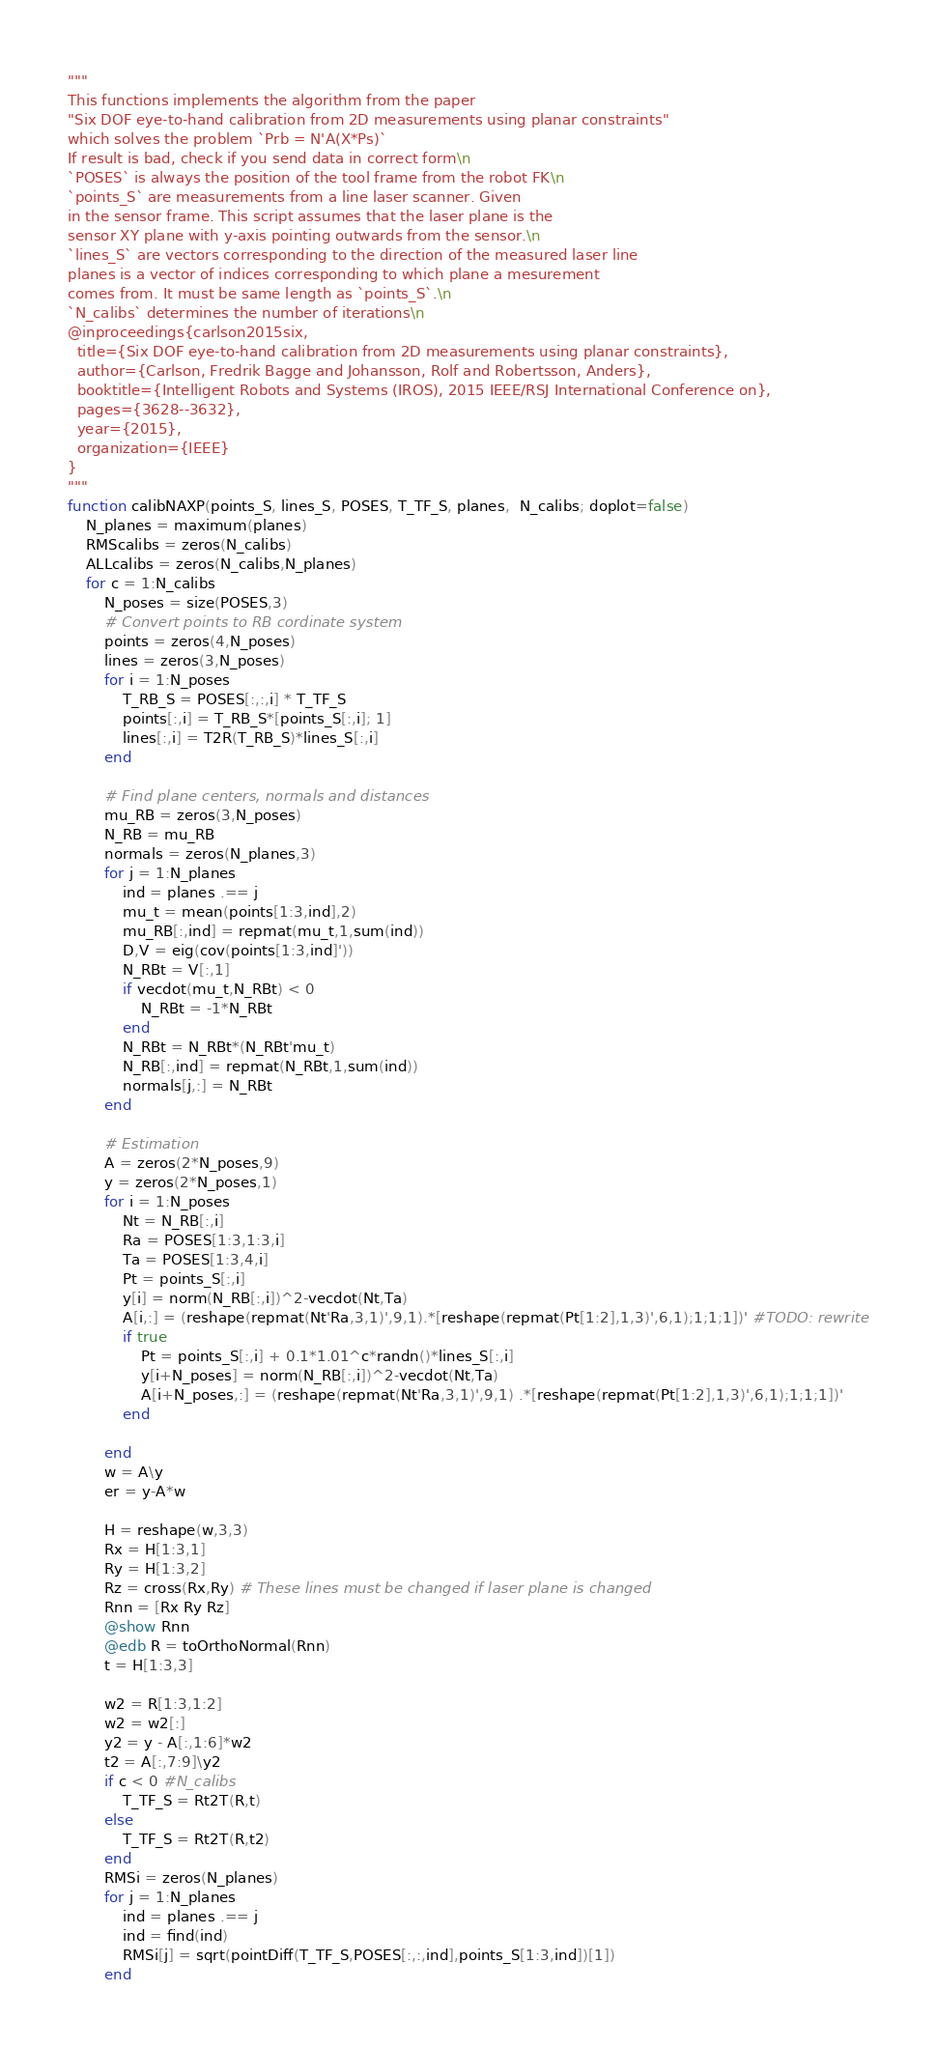Convert code to text. <code><loc_0><loc_0><loc_500><loc_500><_Julia_>"""
This functions implements the algorithm from the paper
"Six DOF eye-to-hand calibration from 2D measurements using planar constraints"
which solves the problem `Prb = N'A(X*Ps)`
If result is bad, check if you send data in correct form\n
`POSES` is always the position of the tool frame from the robot FK\n
`points_S` are measurements from a line laser scanner. Given
in the sensor frame. This script assumes that the laser plane is the
sensor XY plane with y-axis pointing outwards from the sensor.\n
`lines_S` are vectors corresponding to the direction of the measured laser line
planes is a vector of indices corresponding to which plane a mesurement
comes from. It must be same length as `points_S`.\n
`N_calibs` determines the number of iterations\n
@inproceedings{carlson2015six,
  title={Six DOF eye-to-hand calibration from 2D measurements using planar constraints},
  author={Carlson, Fredrik Bagge and Johansson, Rolf and Robertsson, Anders},
  booktitle={Intelligent Robots and Systems (IROS), 2015 IEEE/RSJ International Conference on},
  pages={3628--3632},
  year={2015},
  organization={IEEE}
}
"""
function calibNAXP(points_S, lines_S, POSES, T_TF_S, planes,  N_calibs; doplot=false)
    N_planes = maximum(planes)
    RMScalibs = zeros(N_calibs)
    ALLcalibs = zeros(N_calibs,N_planes)
    for c = 1:N_calibs
        N_poses = size(POSES,3)
        # Convert points to RB cordinate system
        points = zeros(4,N_poses)
        lines = zeros(3,N_poses)
        for i = 1:N_poses
            T_RB_S = POSES[:,:,i] * T_TF_S
            points[:,i] = T_RB_S*[points_S[:,i]; 1]
            lines[:,i] = T2R(T_RB_S)*lines_S[:,i]
        end

        # Find plane centers, normals and distances
        mu_RB = zeros(3,N_poses)
        N_RB = mu_RB
        normals = zeros(N_planes,3)
        for j = 1:N_planes
            ind = planes .== j
            mu_t = mean(points[1:3,ind],2)
            mu_RB[:,ind] = repmat(mu_t,1,sum(ind))
            D,V = eig(cov(points[1:3,ind]'))
            N_RBt = V[:,1]
            if vecdot(mu_t,N_RBt) < 0
                N_RBt = -1*N_RBt
            end
            N_RBt = N_RBt*(N_RBt'mu_t)
            N_RB[:,ind] = repmat(N_RBt,1,sum(ind))
            normals[j,:] = N_RBt
        end

        # Estimation
        A = zeros(2*N_poses,9)
        y = zeros(2*N_poses,1)
        for i = 1:N_poses
            Nt = N_RB[:,i]
            Ra = POSES[1:3,1:3,i]
            Ta = POSES[1:3,4,i]
            Pt = points_S[:,i]
            y[i] = norm(N_RB[:,i])^2-vecdot(Nt,Ta)
            A[i,:] = (reshape(repmat(Nt'Ra,3,1)',9,1).*[reshape(repmat(Pt[1:2],1,3)',6,1);1;1;1])' #TODO: rewrite
            if true
                Pt = points_S[:,i] + 0.1*1.01^c*randn()*lines_S[:,i]
                y[i+N_poses] = norm(N_RB[:,i])^2-vecdot(Nt,Ta)
                A[i+N_poses,:] = (reshape(repmat(Nt'Ra,3,1)',9,1) .*[reshape(repmat(Pt[1:2],1,3)',6,1);1;1;1])'
            end

        end
        w = A\y
        er = y-A*w

        H = reshape(w,3,3)
        Rx = H[1:3,1]
        Ry = H[1:3,2]
        Rz = cross(Rx,Ry) # These lines must be changed if laser plane is changed
        Rnn = [Rx Ry Rz]
        @show Rnn
        @edb R = toOrthoNormal(Rnn)
        t = H[1:3,3]

        w2 = R[1:3,1:2]
        w2 = w2[:]
        y2 = y - A[:,1:6]*w2
        t2 = A[:,7:9]\y2
        if c < 0 #N_calibs
            T_TF_S = Rt2T(R,t)
        else
            T_TF_S = Rt2T(R,t2)
        end
        RMSi = zeros(N_planes)
        for j = 1:N_planes
            ind = planes .== j
            ind = find(ind)
            RMSi[j] = sqrt(pointDiff(T_TF_S,POSES[:,:,ind],points_S[1:3,ind])[1])
        end</code> 